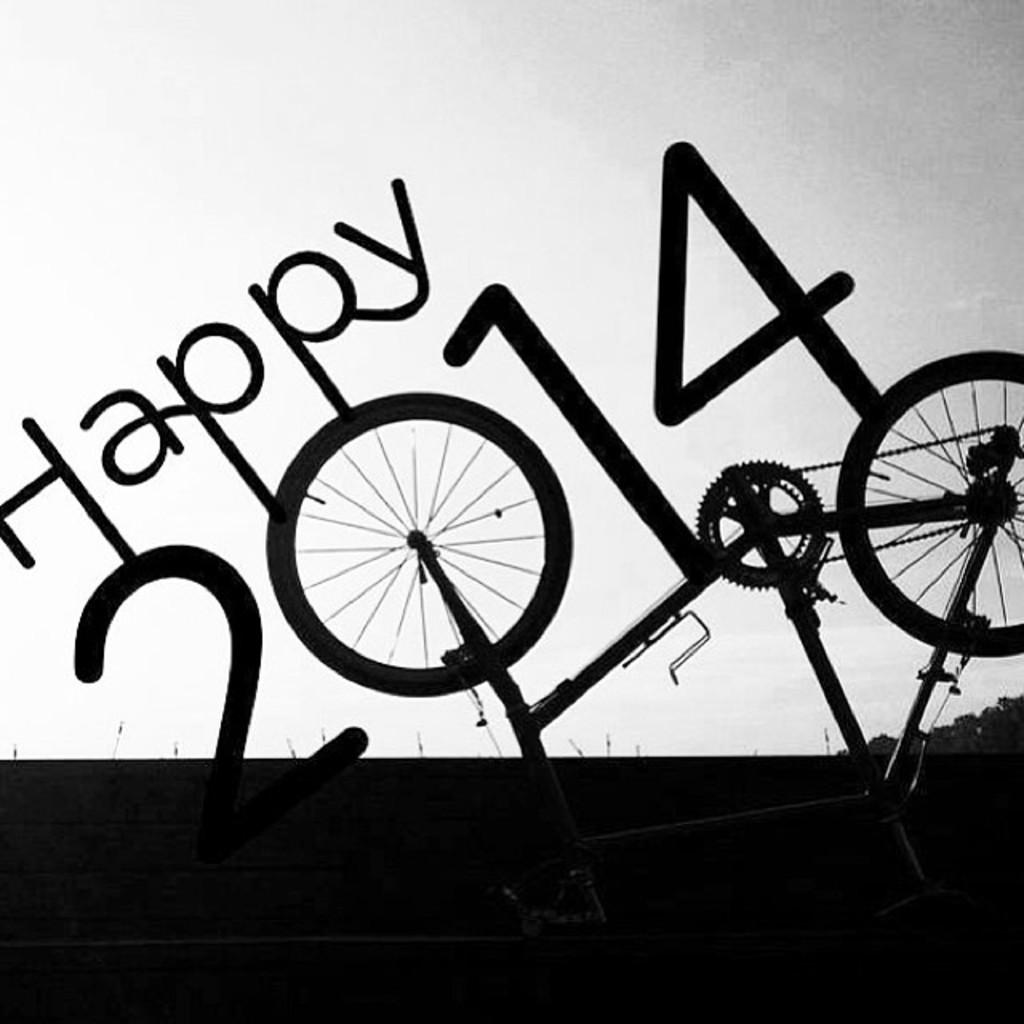What is the main subject of the image? The main subject of the image is a text poster. What does the text on the poster say? The text on the poster says "happy 2014". What other object is visible in the image? There is a bicycle in the image. What type of poison is being used to clean the bicycle in the image? There is no poison present in the image, and the bicycle is not being cleaned. Can you see any bones in the image? There are no bones visible in the image. 